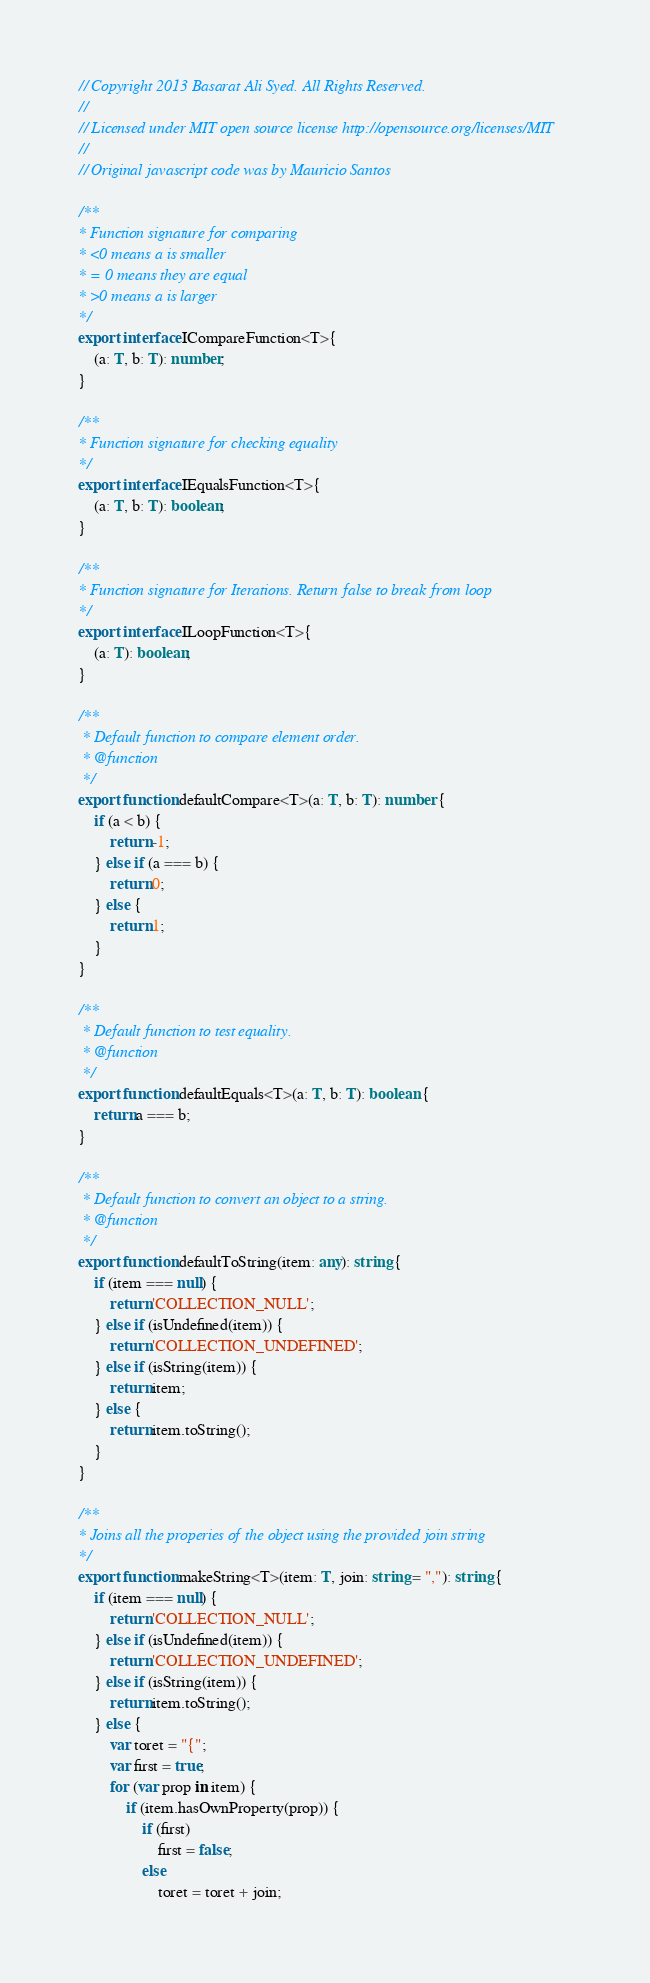Convert code to text. <code><loc_0><loc_0><loc_500><loc_500><_TypeScript_>// Copyright 2013 Basarat Ali Syed. All Rights Reserved.
//
// Licensed under MIT open source license http://opensource.org/licenses/MIT
//
// Original javascript code was by Mauricio Santos

/**
* Function signature for comparing
* <0 means a is smaller
* = 0 means they are equal
* >0 means a is larger
*/
export interface ICompareFunction<T>{
    (a: T, b: T): number;
}

/**
* Function signature for checking equality
*/
export interface IEqualsFunction<T>{
    (a: T, b: T): boolean;
}

/**
* Function signature for Iterations. Return false to break from loop
*/
export interface ILoopFunction<T>{
    (a: T): boolean;
}

/**
 * Default function to compare element order.
 * @function
 */
export function defaultCompare<T>(a: T, b: T): number {
    if (a < b) {
        return -1;
    } else if (a === b) {
        return 0;
    } else {
        return 1;
    }
}

/**
 * Default function to test equality.
 * @function
 */
export function defaultEquals<T>(a: T, b: T): boolean {
    return a === b;
}

/**
 * Default function to convert an object to a string.
 * @function
 */
export function defaultToString(item: any): string {
    if (item === null) {
        return 'COLLECTION_NULL';
    } else if (isUndefined(item)) {
        return 'COLLECTION_UNDEFINED';
    } else if (isString(item)) {
        return item;
    } else {
        return item.toString();
    }
}

/**
* Joins all the properies of the object using the provided join string
*/
export function makeString<T>(item: T, join: string = ","): string {
    if (item === null) {
        return 'COLLECTION_NULL';
    } else if (isUndefined(item)) {
        return 'COLLECTION_UNDEFINED';
    } else if (isString(item)) {
        return item.toString();
    } else {
        var toret = "{";
        var first = true;
        for (var prop in item) {
            if (item.hasOwnProperty(prop)) {
                if (first)
                    first = false;
                else
                    toret = toret + join;</code> 